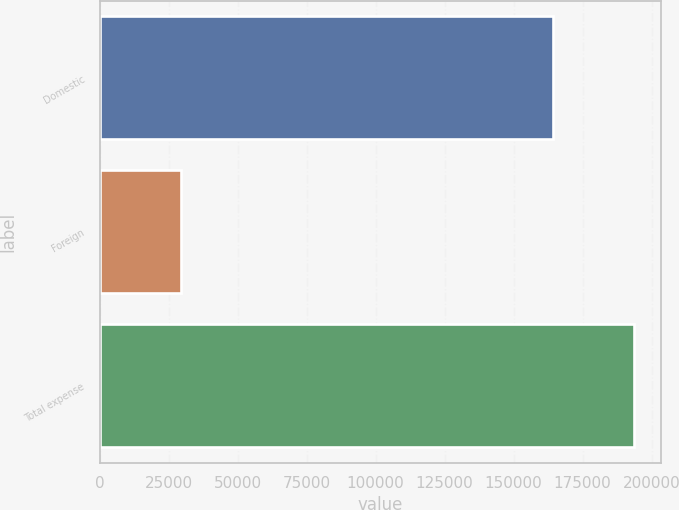Convert chart to OTSL. <chart><loc_0><loc_0><loc_500><loc_500><bar_chart><fcel>Domestic<fcel>Foreign<fcel>Total expense<nl><fcel>164172<fcel>29415<fcel>193587<nl></chart> 